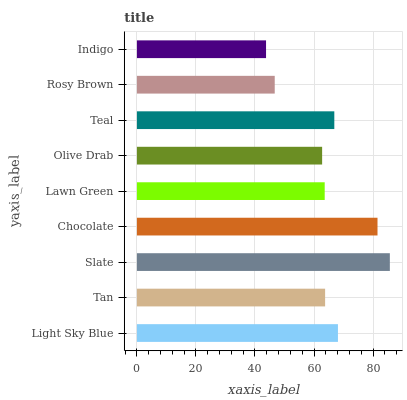Is Indigo the minimum?
Answer yes or no. Yes. Is Slate the maximum?
Answer yes or no. Yes. Is Tan the minimum?
Answer yes or no. No. Is Tan the maximum?
Answer yes or no. No. Is Light Sky Blue greater than Tan?
Answer yes or no. Yes. Is Tan less than Light Sky Blue?
Answer yes or no. Yes. Is Tan greater than Light Sky Blue?
Answer yes or no. No. Is Light Sky Blue less than Tan?
Answer yes or no. No. Is Tan the high median?
Answer yes or no. Yes. Is Tan the low median?
Answer yes or no. Yes. Is Olive Drab the high median?
Answer yes or no. No. Is Chocolate the low median?
Answer yes or no. No. 